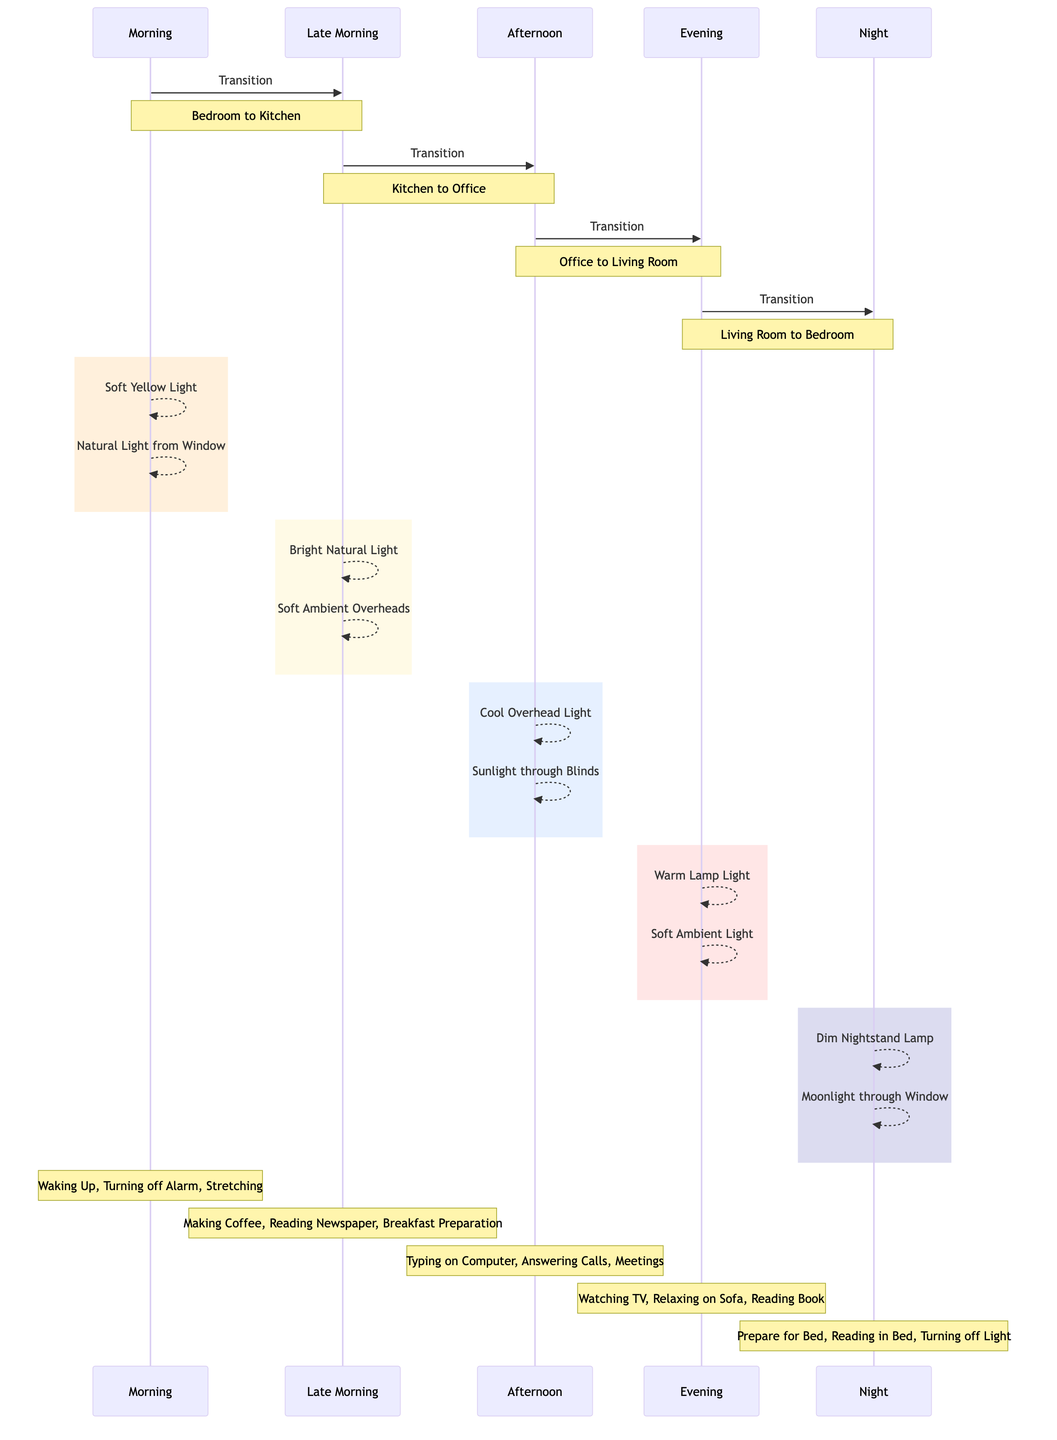What is the first time period shown in the diagram? The diagram starts with the "Morning" time period as it is the first participant listed.
Answer: Morning How many time periods are represented in the diagram? The diagram includes five distinct time periods: Morning, Late Morning, Afternoon, Evening, and Night, making a total of five.
Answer: 5 What activity is associated with the Evening period? The Evening period mentions "Watching TV," which is one of the activities listed for that time.
Answer: Watching TV What type of lighting is used in the Afternoon period? The Afternoon period uses "Cool Overhead Light" and "Sunlight through Blinds," indicating the lighting style for that time.
Answer: Cool Overhead Light, Sunlight through Blinds Which two locations are part of the transition from Late Morning to Afternoon? The transition goes from "Kitchen" to "Office," as indicated by the endpoints of that transition.
Answer: Kitchen, Office What is the last activity mentioned before the Night period? The last listed activity before transitioning to the Night period is "Reading in Bed," which is the last activity in the Evening period.
Answer: Reading in Bed How does the lighting change from 'Morning' to 'Late Morning'? The lighting changes from "Soft Yellow Light" and "Natural Light from Window" in the Morning to "Bright Natural Light" and "Soft Ambient Overheads" in Late Morning.
Answer: Soft Yellow Light, Bright Natural Light What sets the mood for the Night period? The Night period is characterized by "Dim Nightstand Lamp" and "Moonlight through Window," which creates a calm and quiet atmosphere.
Answer: Dim Nightstand Lamp, Moonlight through Window Which activity occurs during the Late Morning stage? One activity that occurs during the Late Morning stage is "Making Coffee," as listed under that time period.
Answer: Making Coffee 